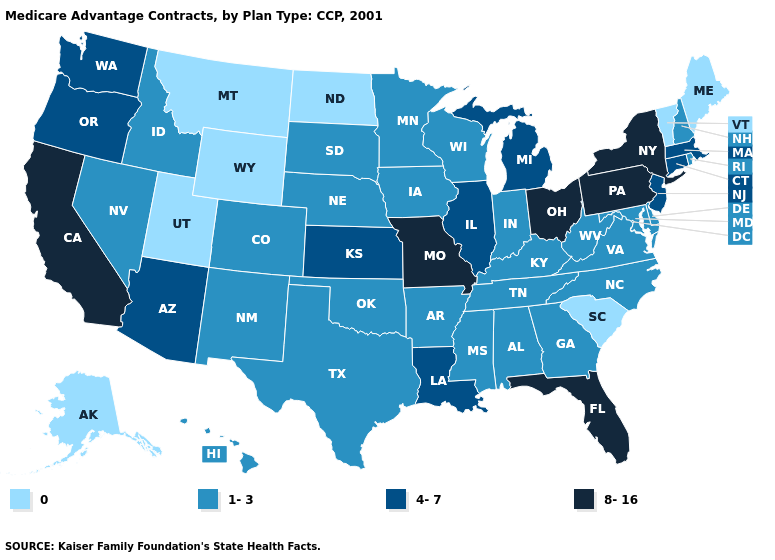What is the value of Louisiana?
Quick response, please. 4-7. Name the states that have a value in the range 0?
Keep it brief. Alaska, Maine, Montana, North Dakota, South Carolina, Utah, Vermont, Wyoming. What is the value of Pennsylvania?
Keep it brief. 8-16. Among the states that border Idaho , which have the highest value?
Concise answer only. Oregon, Washington. Does Nevada have the lowest value in the USA?
Answer briefly. No. What is the lowest value in states that border Washington?
Write a very short answer. 1-3. Does Montana have the lowest value in the USA?
Keep it brief. Yes. What is the value of Ohio?
Give a very brief answer. 8-16. Is the legend a continuous bar?
Keep it brief. No. What is the highest value in states that border Utah?
Give a very brief answer. 4-7. What is the highest value in the USA?
Write a very short answer. 8-16. What is the highest value in states that border South Dakota?
Short answer required. 1-3. Does Ohio have the highest value in the MidWest?
Keep it brief. Yes. What is the lowest value in the USA?
Give a very brief answer. 0. 